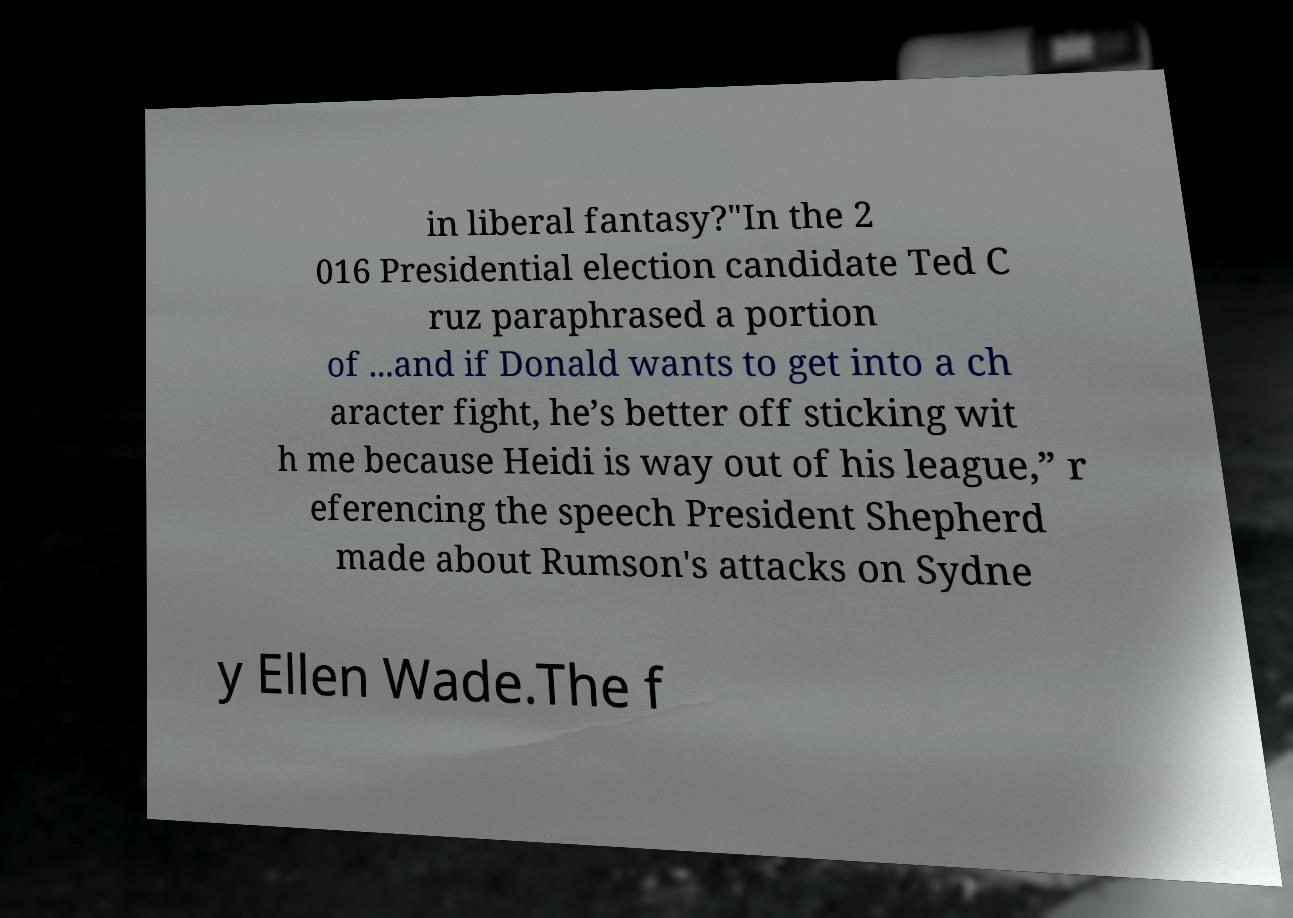Could you assist in decoding the text presented in this image and type it out clearly? in liberal fantasy?"In the 2 016 Presidential election candidate Ted C ruz paraphrased a portion of ...and if Donald wants to get into a ch aracter fight, he’s better off sticking wit h me because Heidi is way out of his league,” r eferencing the speech President Shepherd made about Rumson's attacks on Sydne y Ellen Wade.The f 